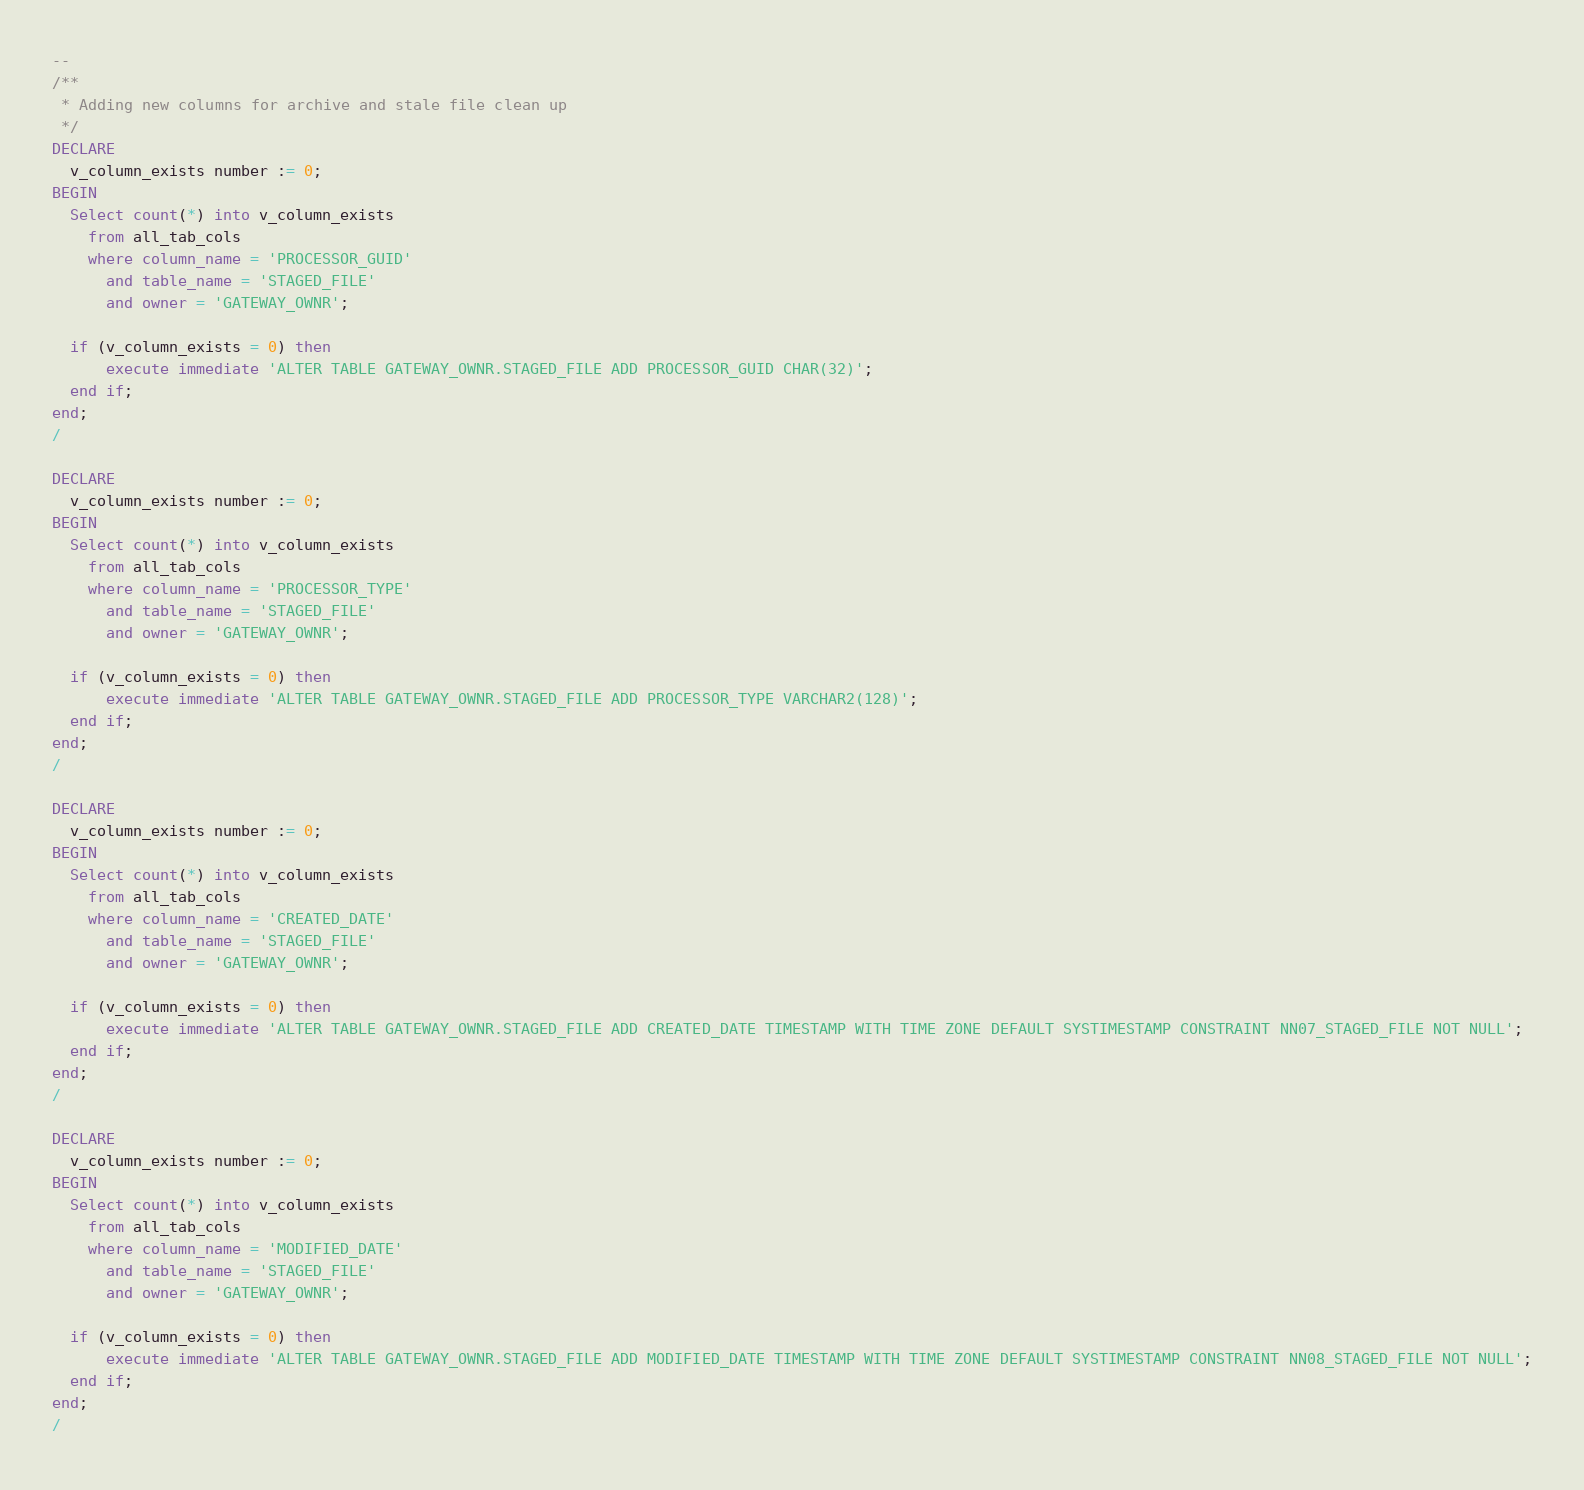<code> <loc_0><loc_0><loc_500><loc_500><_SQL_>--
/**
 * Adding new columns for archive and stale file clean up
 */
DECLARE
  v_column_exists number := 0;  
BEGIN
  Select count(*) into v_column_exists
    from all_tab_cols
    where column_name = 'PROCESSOR_GUID'
      and table_name = 'STAGED_FILE'
      and owner = 'GATEWAY_OWNR';

  if (v_column_exists = 0) then
      execute immediate 'ALTER TABLE GATEWAY_OWNR.STAGED_FILE ADD PROCESSOR_GUID CHAR(32)';
  end if;
end;
/

DECLARE
  v_column_exists number := 0;  
BEGIN
  Select count(*) into v_column_exists
    from all_tab_cols
    where column_name = 'PROCESSOR_TYPE'
      and table_name = 'STAGED_FILE'
      and owner = 'GATEWAY_OWNR';

  if (v_column_exists = 0) then
      execute immediate 'ALTER TABLE GATEWAY_OWNR.STAGED_FILE ADD PROCESSOR_TYPE VARCHAR2(128)';
  end if;
end;
/

DECLARE
  v_column_exists number := 0;  
BEGIN
  Select count(*) into v_column_exists
    from all_tab_cols
    where column_name = 'CREATED_DATE'
      and table_name = 'STAGED_FILE'
      and owner = 'GATEWAY_OWNR';

  if (v_column_exists = 0) then
      execute immediate 'ALTER TABLE GATEWAY_OWNR.STAGED_FILE ADD CREATED_DATE TIMESTAMP WITH TIME ZONE DEFAULT SYSTIMESTAMP CONSTRAINT NN07_STAGED_FILE NOT NULL';
  end if;
end;
/

DECLARE
  v_column_exists number := 0;  
BEGIN
  Select count(*) into v_column_exists
    from all_tab_cols
    where column_name = 'MODIFIED_DATE'
      and table_name = 'STAGED_FILE'
      and owner = 'GATEWAY_OWNR';

  if (v_column_exists = 0) then
      execute immediate 'ALTER TABLE GATEWAY_OWNR.STAGED_FILE ADD MODIFIED_DATE TIMESTAMP WITH TIME ZONE DEFAULT SYSTIMESTAMP CONSTRAINT NN08_STAGED_FILE NOT NULL';
  end if;
end;
/

</code> 